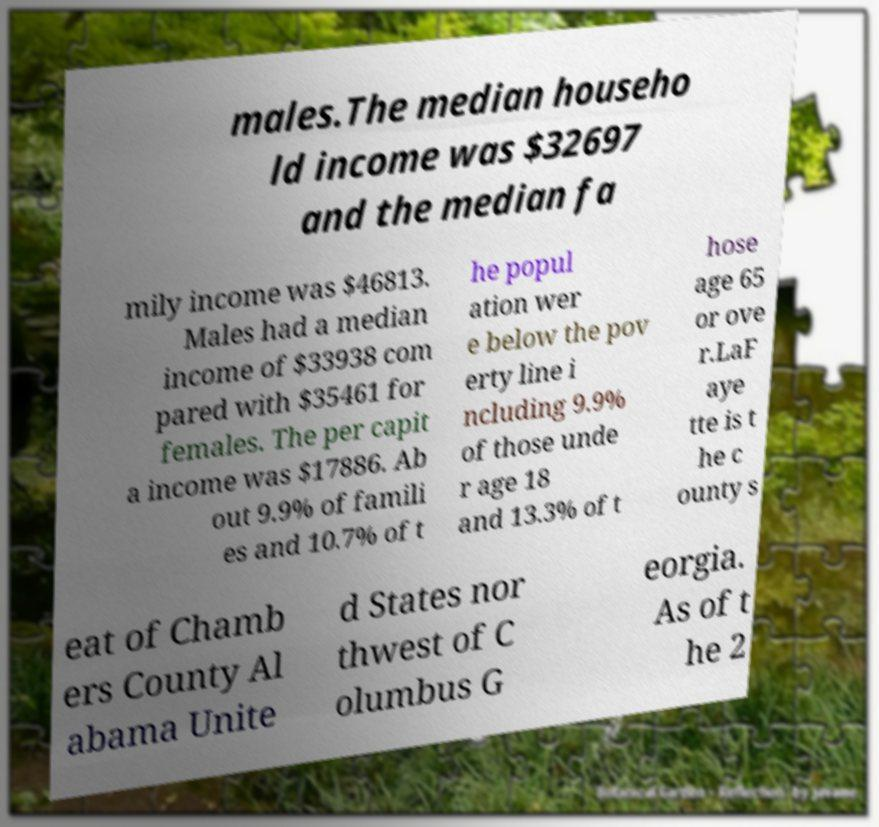Please identify and transcribe the text found in this image. males.The median househo ld income was $32697 and the median fa mily income was $46813. Males had a median income of $33938 com pared with $35461 for females. The per capit a income was $17886. Ab out 9.9% of famili es and 10.7% of t he popul ation wer e below the pov erty line i ncluding 9.9% of those unde r age 18 and 13.3% of t hose age 65 or ove r.LaF aye tte is t he c ounty s eat of Chamb ers County Al abama Unite d States nor thwest of C olumbus G eorgia. As of t he 2 